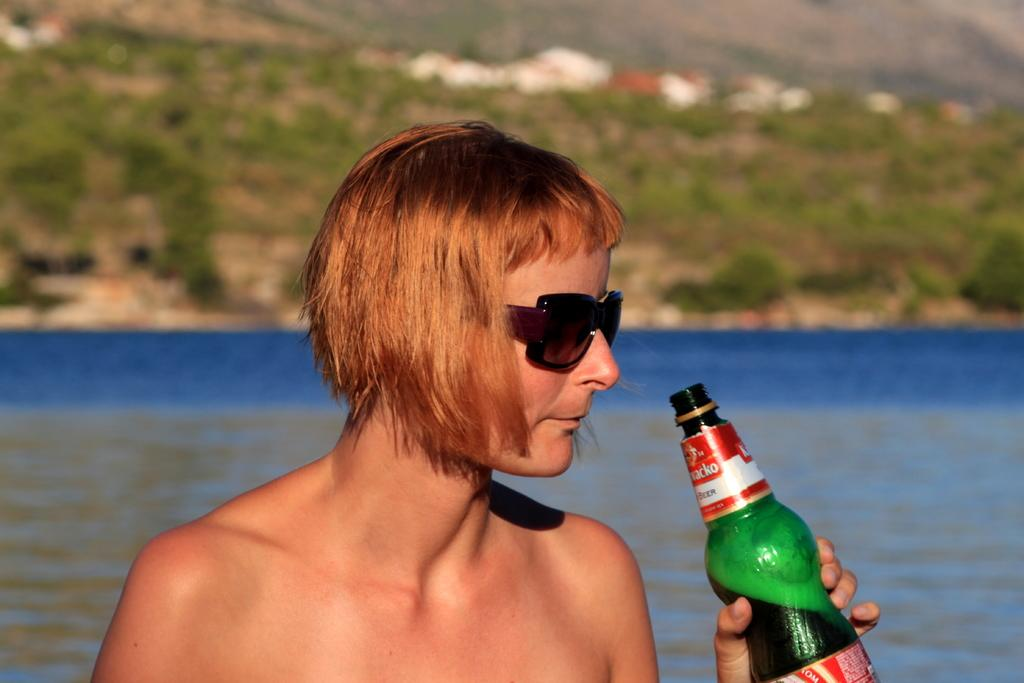Where was the image taken? The image is taken outside. What can be seen in the background of the image? There is water visible in the image. Can you describe the person in the image? There is a person standing in the image, and he is holding a bottle in his hand and wearing goggles. What type of thrill is the person experiencing while holding the bottle in the image? There is no indication of any thrill in the image; the person is simply standing and holding a bottle. What tools might the carpenter be using in the image? There is no carpenter or any tools present in the image. What type of oatmeal is being prepared in the image? There is no oatmeal or any cooking activity present in the image. 